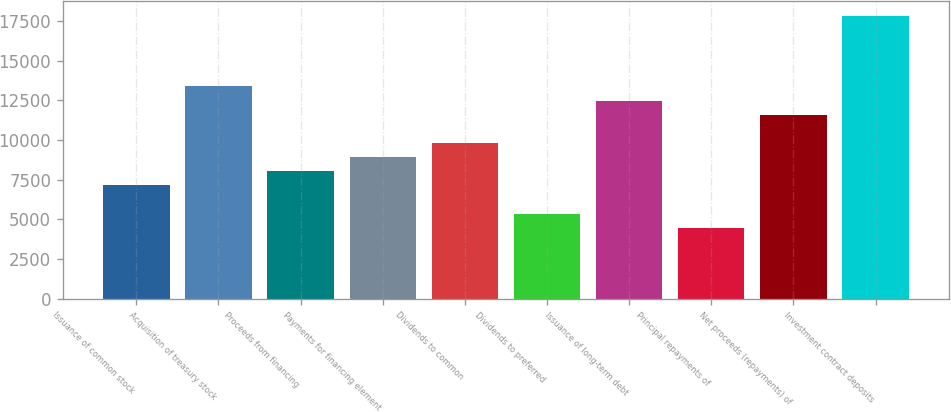<chart> <loc_0><loc_0><loc_500><loc_500><bar_chart><fcel>Issuance of common stock<fcel>Acquisition of treasury stock<fcel>Proceeds from financing<fcel>Payments for financing element<fcel>Dividends to common<fcel>Dividends to preferred<fcel>Issuance of long-term debt<fcel>Principal repayments of<fcel>Net proceeds (repayments) of<fcel>Investment contract deposits<nl><fcel>7140.68<fcel>13388.2<fcel>8033.19<fcel>8925.7<fcel>9818.21<fcel>5355.66<fcel>12495.7<fcel>4463.15<fcel>11603.2<fcel>17850.8<nl></chart> 